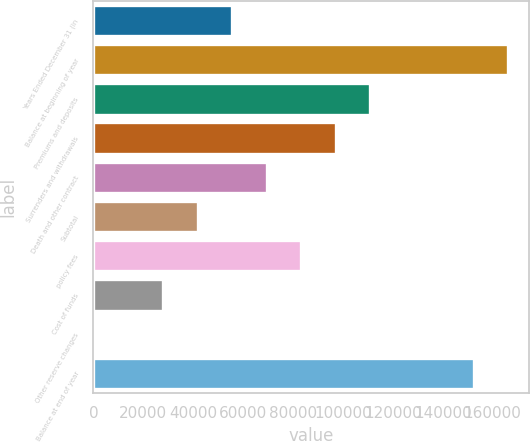<chart> <loc_0><loc_0><loc_500><loc_500><bar_chart><fcel>Years Ended December 31 (in<fcel>Balance at beginning of year<fcel>Premiums and deposits<fcel>Surrenders and withdrawals<fcel>Death and other contract<fcel>Subtotal<fcel>policy fees<fcel>Cost of funds<fcel>Other reserve changes<fcel>Balance at end of year<nl><fcel>55610.8<fcel>166224<fcel>110918<fcel>97090.9<fcel>69437.5<fcel>41784.1<fcel>83264.2<fcel>27957.4<fcel>304<fcel>152398<nl></chart> 